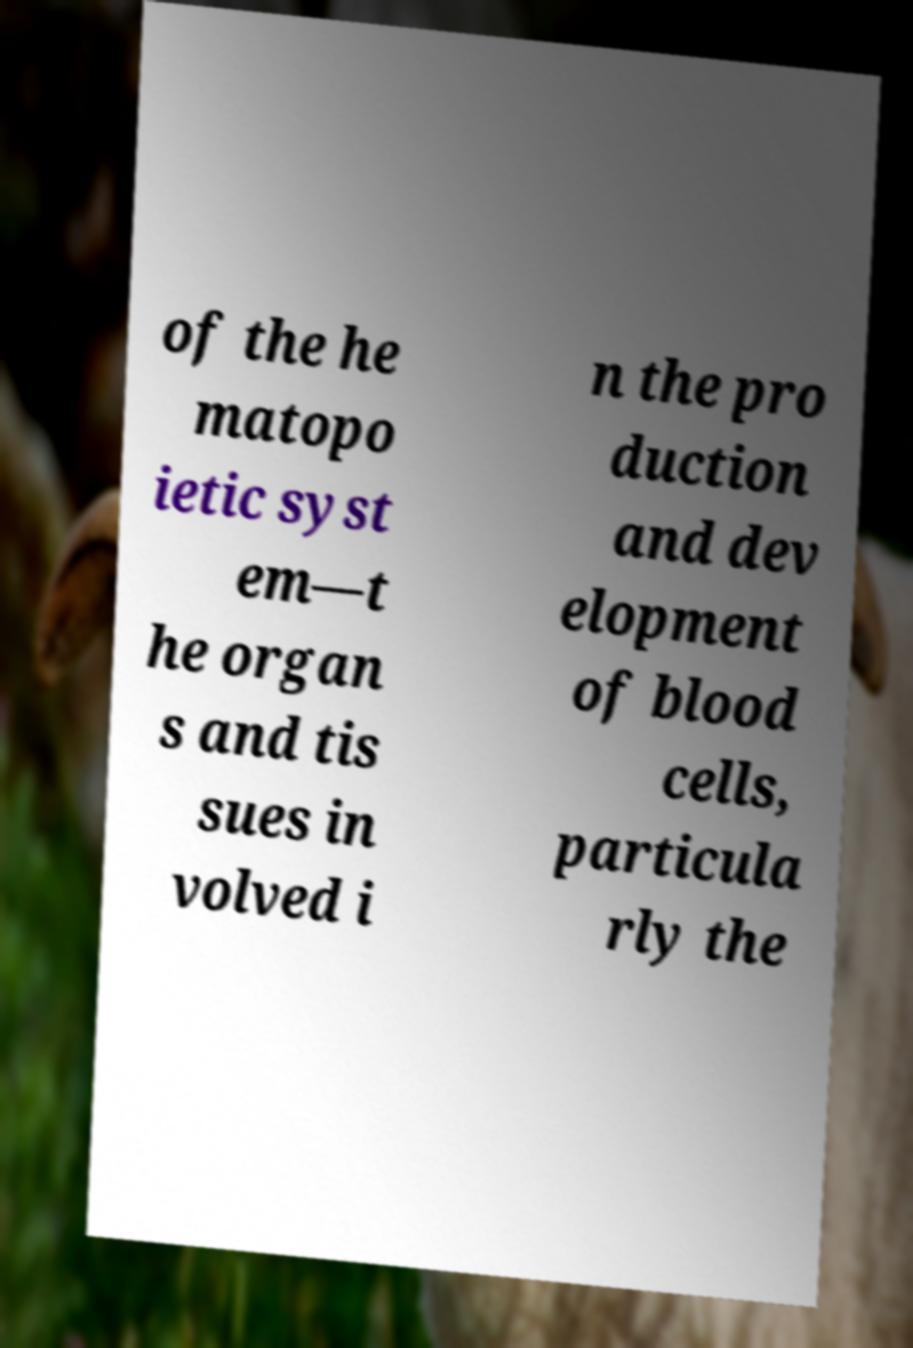For documentation purposes, I need the text within this image transcribed. Could you provide that? of the he matopo ietic syst em—t he organ s and tis sues in volved i n the pro duction and dev elopment of blood cells, particula rly the 